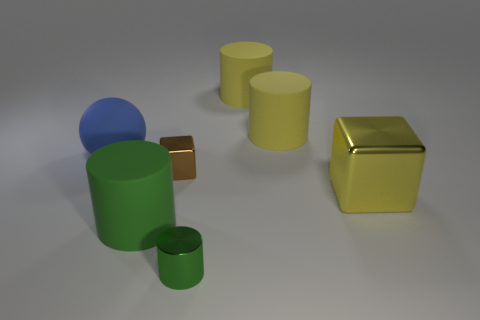What's the texture of the blue object? The blue object has a smooth, matte finish. Unlike some of the shiny metallic surfaces in the image, it doesn't reflect the light and thus appears to have a velvety texture. Is that blue object solid or hollow? While the image does not provide a direct view of its solidity, the object's uniform appearance and the context within the image suggest it is likely a solid shape. 